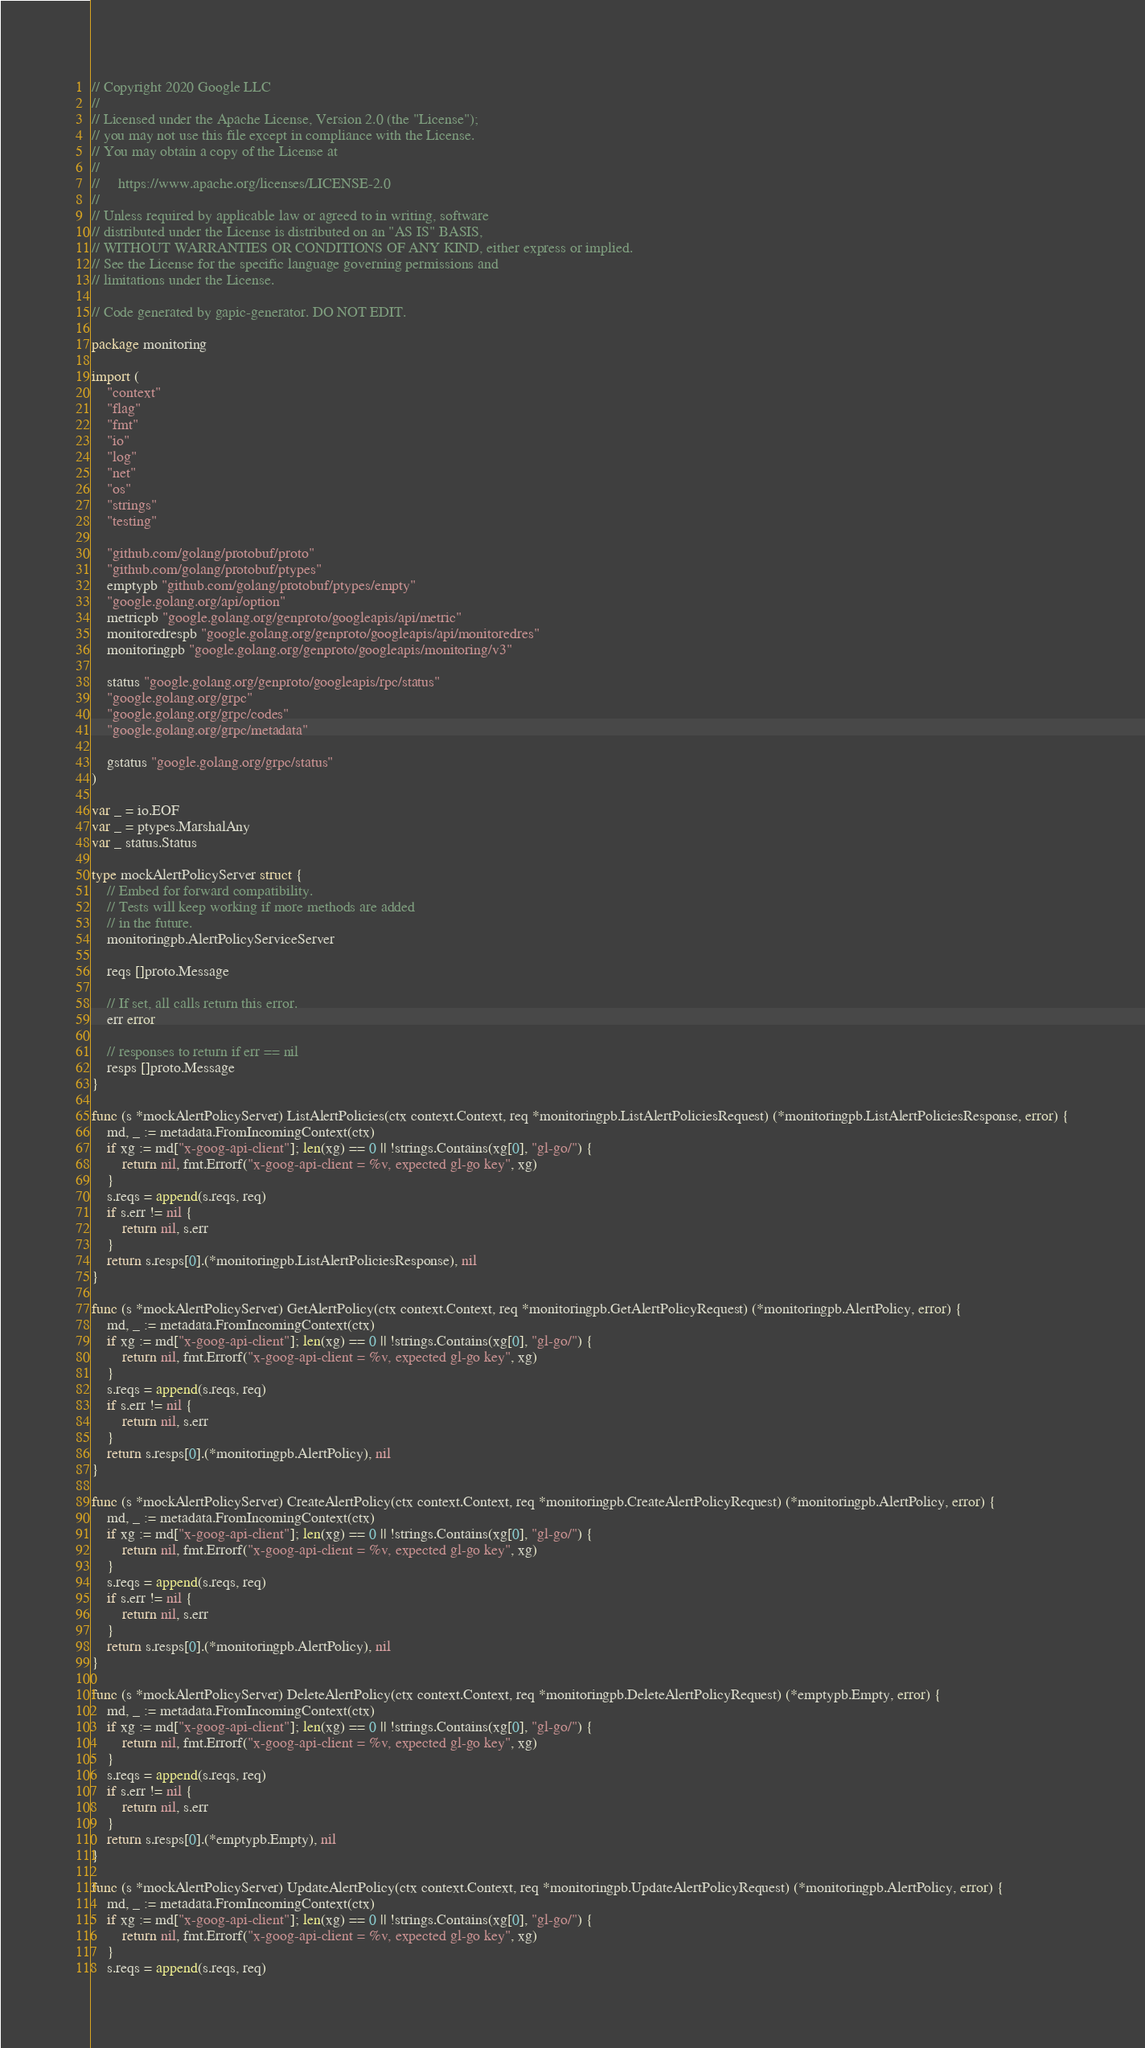Convert code to text. <code><loc_0><loc_0><loc_500><loc_500><_Go_>// Copyright 2020 Google LLC
//
// Licensed under the Apache License, Version 2.0 (the "License");
// you may not use this file except in compliance with the License.
// You may obtain a copy of the License at
//
//     https://www.apache.org/licenses/LICENSE-2.0
//
// Unless required by applicable law or agreed to in writing, software
// distributed under the License is distributed on an "AS IS" BASIS,
// WITHOUT WARRANTIES OR CONDITIONS OF ANY KIND, either express or implied.
// See the License for the specific language governing permissions and
// limitations under the License.

// Code generated by gapic-generator. DO NOT EDIT.

package monitoring

import (
	"context"
	"flag"
	"fmt"
	"io"
	"log"
	"net"
	"os"
	"strings"
	"testing"

	"github.com/golang/protobuf/proto"
	"github.com/golang/protobuf/ptypes"
	emptypb "github.com/golang/protobuf/ptypes/empty"
	"google.golang.org/api/option"
	metricpb "google.golang.org/genproto/googleapis/api/metric"
	monitoredrespb "google.golang.org/genproto/googleapis/api/monitoredres"
	monitoringpb "google.golang.org/genproto/googleapis/monitoring/v3"

	status "google.golang.org/genproto/googleapis/rpc/status"
	"google.golang.org/grpc"
	"google.golang.org/grpc/codes"
	"google.golang.org/grpc/metadata"

	gstatus "google.golang.org/grpc/status"
)

var _ = io.EOF
var _ = ptypes.MarshalAny
var _ status.Status

type mockAlertPolicyServer struct {
	// Embed for forward compatibility.
	// Tests will keep working if more methods are added
	// in the future.
	monitoringpb.AlertPolicyServiceServer

	reqs []proto.Message

	// If set, all calls return this error.
	err error

	// responses to return if err == nil
	resps []proto.Message
}

func (s *mockAlertPolicyServer) ListAlertPolicies(ctx context.Context, req *monitoringpb.ListAlertPoliciesRequest) (*monitoringpb.ListAlertPoliciesResponse, error) {
	md, _ := metadata.FromIncomingContext(ctx)
	if xg := md["x-goog-api-client"]; len(xg) == 0 || !strings.Contains(xg[0], "gl-go/") {
		return nil, fmt.Errorf("x-goog-api-client = %v, expected gl-go key", xg)
	}
	s.reqs = append(s.reqs, req)
	if s.err != nil {
		return nil, s.err
	}
	return s.resps[0].(*monitoringpb.ListAlertPoliciesResponse), nil
}

func (s *mockAlertPolicyServer) GetAlertPolicy(ctx context.Context, req *monitoringpb.GetAlertPolicyRequest) (*monitoringpb.AlertPolicy, error) {
	md, _ := metadata.FromIncomingContext(ctx)
	if xg := md["x-goog-api-client"]; len(xg) == 0 || !strings.Contains(xg[0], "gl-go/") {
		return nil, fmt.Errorf("x-goog-api-client = %v, expected gl-go key", xg)
	}
	s.reqs = append(s.reqs, req)
	if s.err != nil {
		return nil, s.err
	}
	return s.resps[0].(*monitoringpb.AlertPolicy), nil
}

func (s *mockAlertPolicyServer) CreateAlertPolicy(ctx context.Context, req *monitoringpb.CreateAlertPolicyRequest) (*monitoringpb.AlertPolicy, error) {
	md, _ := metadata.FromIncomingContext(ctx)
	if xg := md["x-goog-api-client"]; len(xg) == 0 || !strings.Contains(xg[0], "gl-go/") {
		return nil, fmt.Errorf("x-goog-api-client = %v, expected gl-go key", xg)
	}
	s.reqs = append(s.reqs, req)
	if s.err != nil {
		return nil, s.err
	}
	return s.resps[0].(*monitoringpb.AlertPolicy), nil
}

func (s *mockAlertPolicyServer) DeleteAlertPolicy(ctx context.Context, req *monitoringpb.DeleteAlertPolicyRequest) (*emptypb.Empty, error) {
	md, _ := metadata.FromIncomingContext(ctx)
	if xg := md["x-goog-api-client"]; len(xg) == 0 || !strings.Contains(xg[0], "gl-go/") {
		return nil, fmt.Errorf("x-goog-api-client = %v, expected gl-go key", xg)
	}
	s.reqs = append(s.reqs, req)
	if s.err != nil {
		return nil, s.err
	}
	return s.resps[0].(*emptypb.Empty), nil
}

func (s *mockAlertPolicyServer) UpdateAlertPolicy(ctx context.Context, req *monitoringpb.UpdateAlertPolicyRequest) (*monitoringpb.AlertPolicy, error) {
	md, _ := metadata.FromIncomingContext(ctx)
	if xg := md["x-goog-api-client"]; len(xg) == 0 || !strings.Contains(xg[0], "gl-go/") {
		return nil, fmt.Errorf("x-goog-api-client = %v, expected gl-go key", xg)
	}
	s.reqs = append(s.reqs, req)</code> 